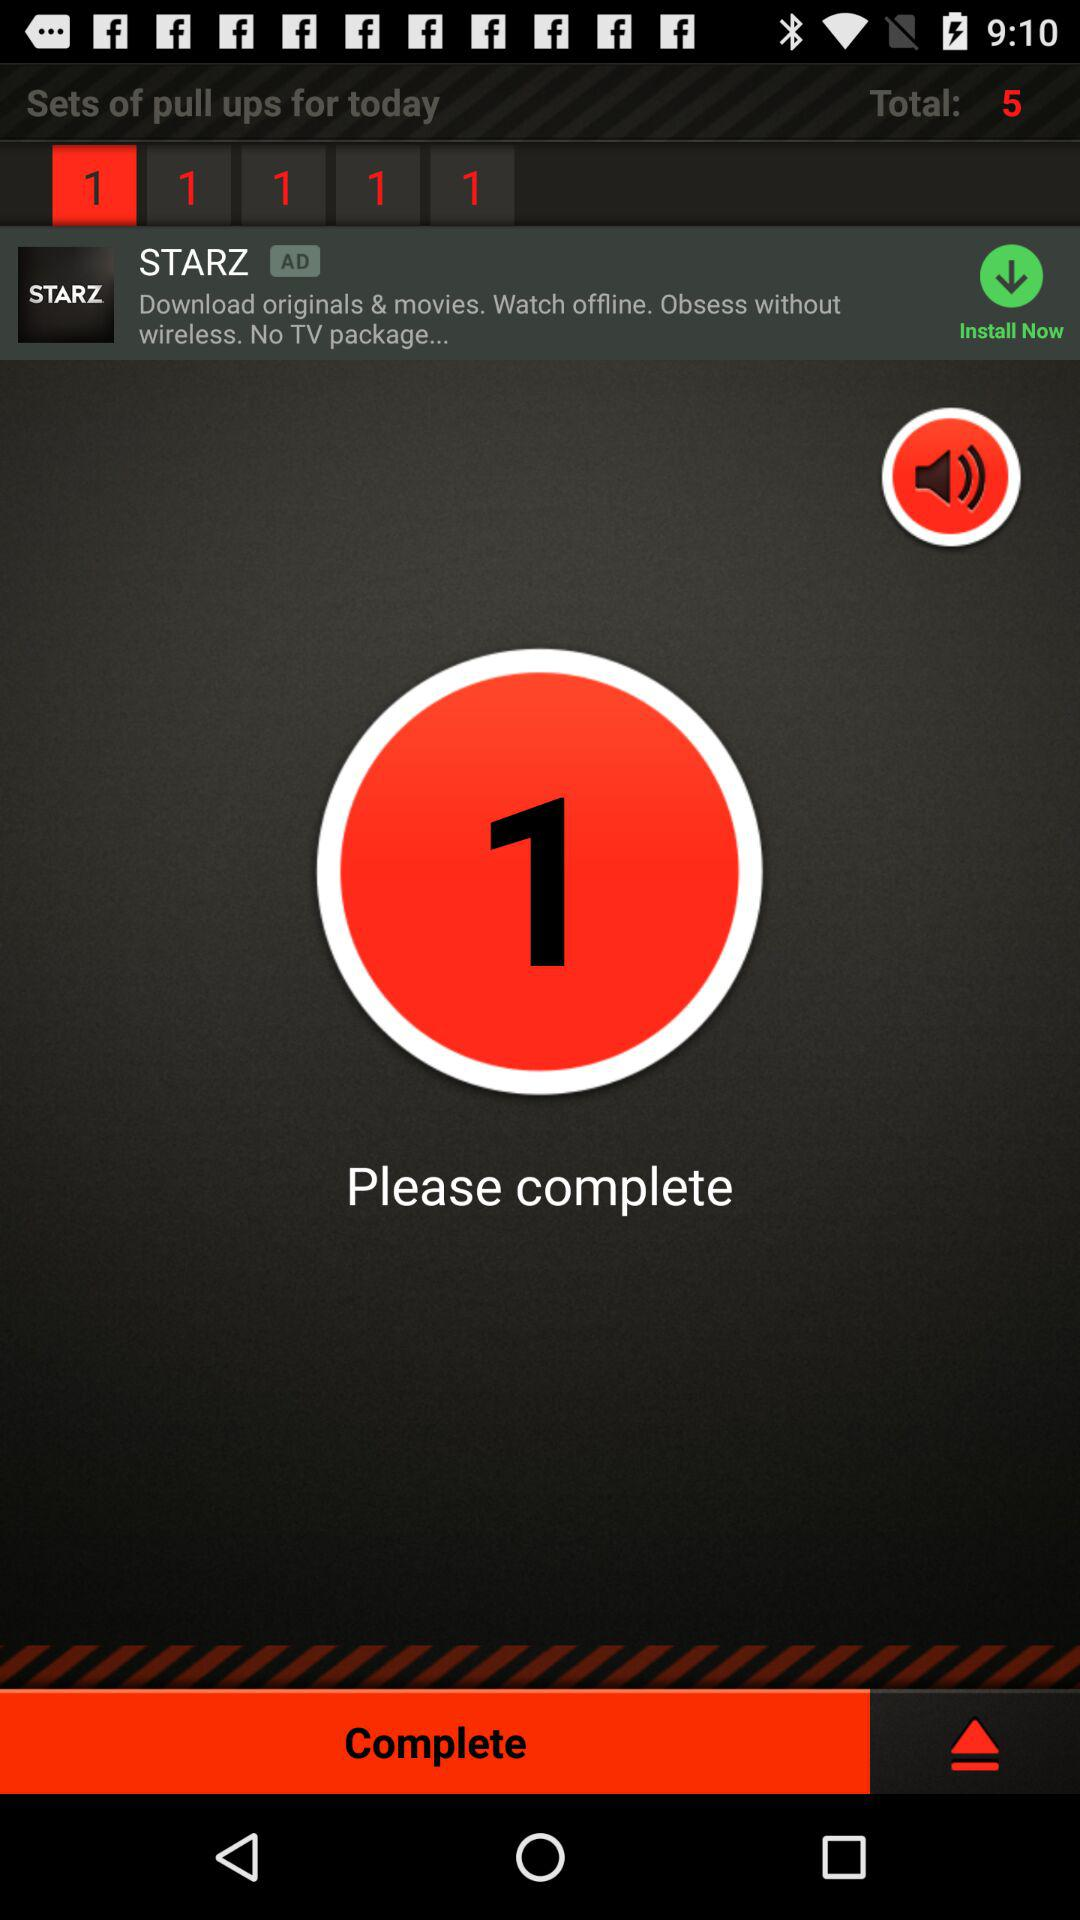How many sets of pull ups are left?
Answer the question using a single word or phrase. 5 